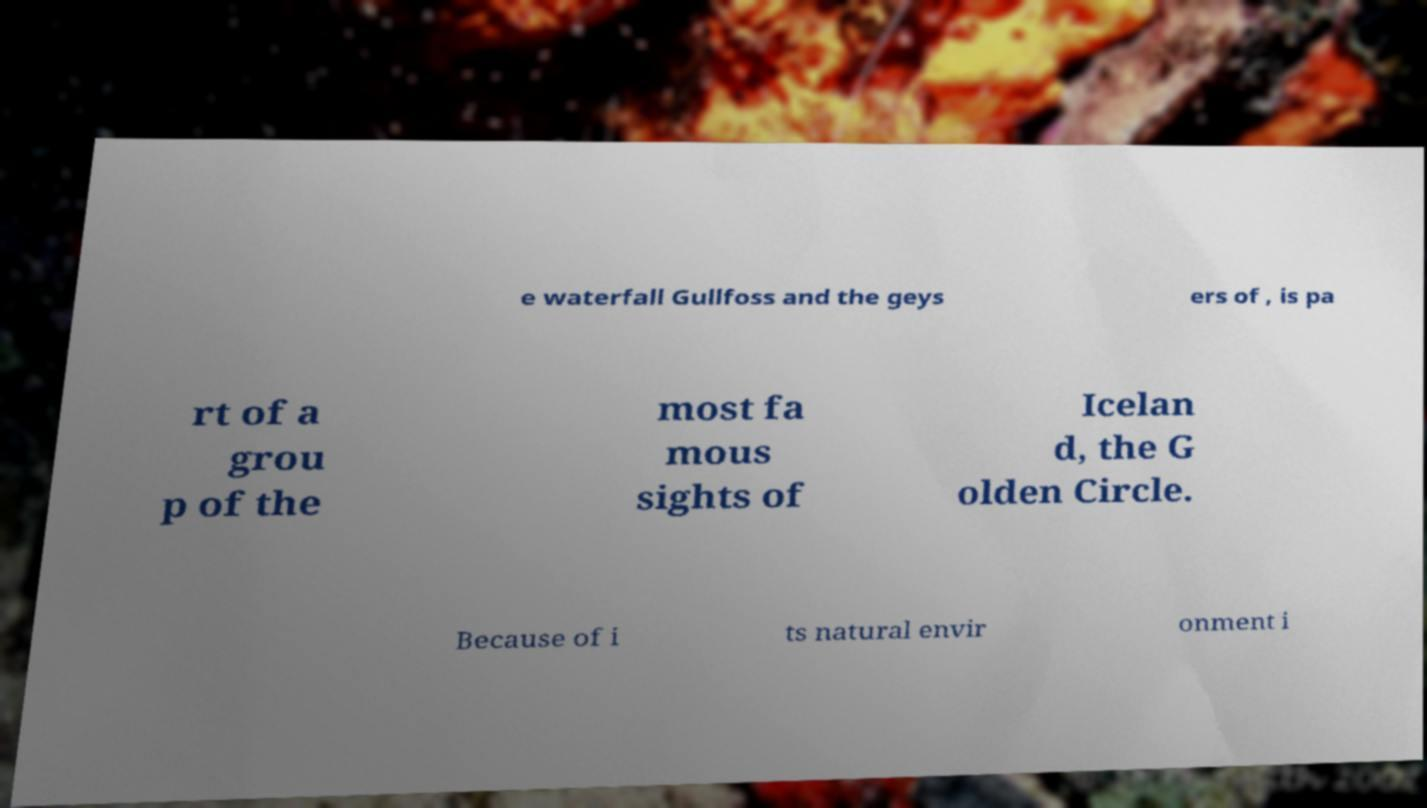Could you extract and type out the text from this image? e waterfall Gullfoss and the geys ers of , is pa rt of a grou p of the most fa mous sights of Icelan d, the G olden Circle. Because of i ts natural envir onment i 